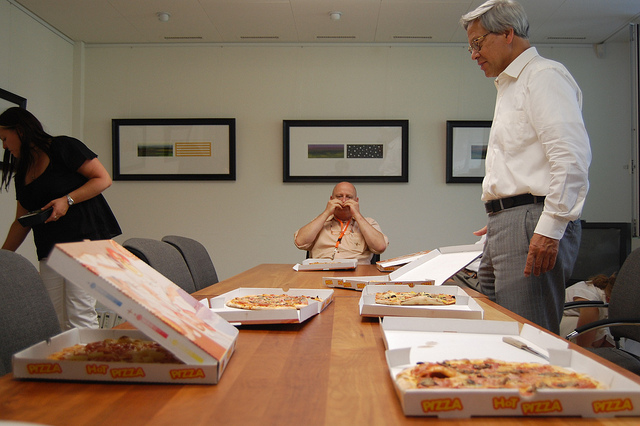<image>How much care is being put into this food's preparation? It's ambiguous how much care is being put into this food's preparation. It can be both little or a lot. How much care is being put into this food's preparation? It is ambiguous how much care is being put into this food's preparation. It can be seen as 'not much', 'lot', 'little' or 'none'. 